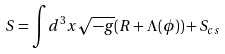Convert formula to latex. <formula><loc_0><loc_0><loc_500><loc_500>S = { \int } d ^ { 3 } x \sqrt { - g } ( R + \Lambda ( \phi ) ) + S _ { c s }</formula> 